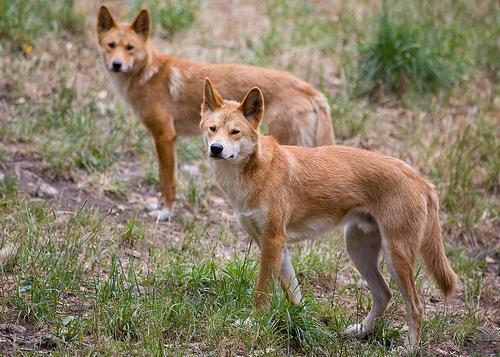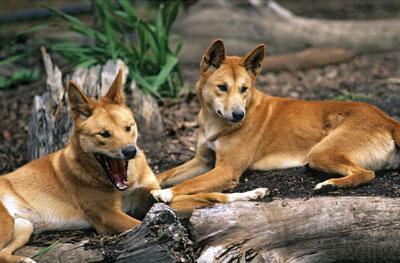The first image is the image on the left, the second image is the image on the right. Considering the images on both sides, is "At least one animal is lying on the ground in the image on the right." valid? Answer yes or no. Yes. 